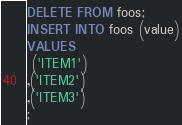Convert code to text. <code><loc_0><loc_0><loc_500><loc_500><_SQL_>DELETE FROM foos;
INSERT INTO foos (value)
VALUES
 ('ITEM1')
,('ITEM2')
,('ITEM3')
;
</code> 